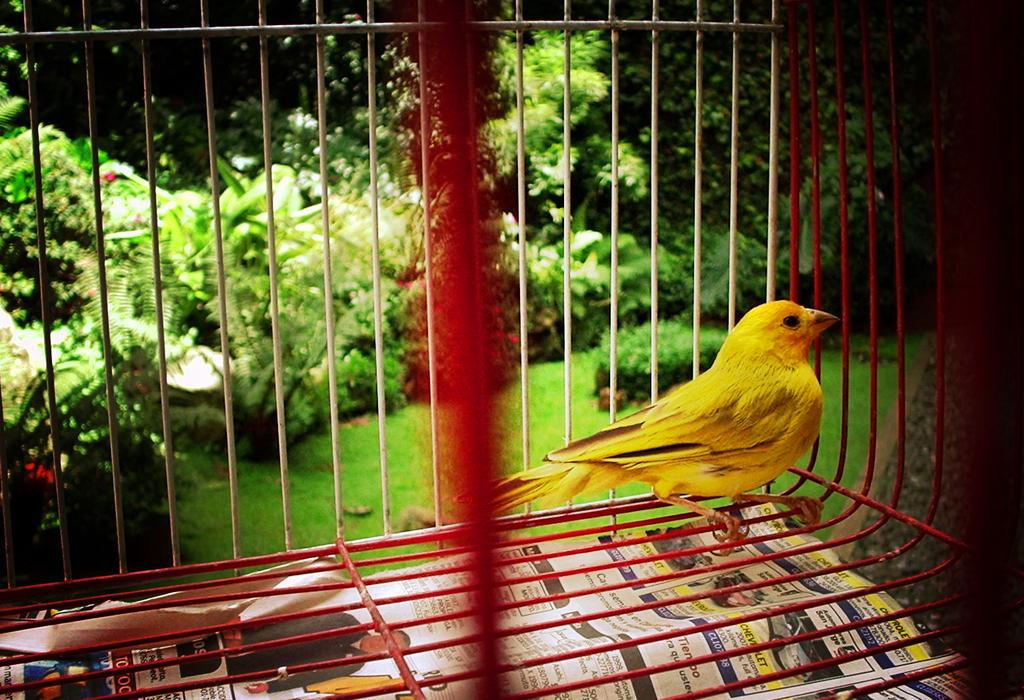What is inside the cage in the image? There is a bird in a cage. What is placed under the cage? There is a paper under the cage. What can be seen in the background of the image? There are trees, plants, and grass in the background of the image. What type of fuel does the bird use to fly in the image? The bird is in a cage and not flying, so it does not use any fuel in the image. 